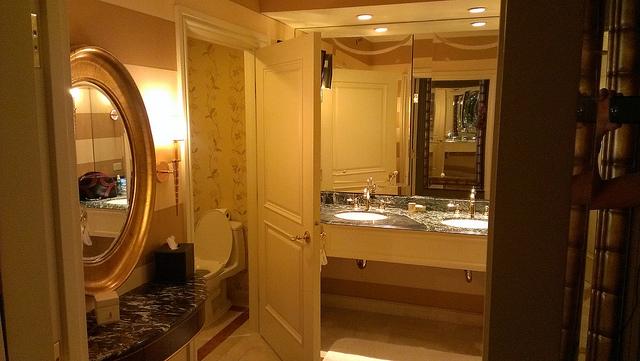What is the color scheme of this room?
Be succinct. Tan. Are the door knob lever style?
Keep it brief. Yes. Can you see more than one reflection?
Give a very brief answer. Yes. What comes out of the black box on the left counter?
Be succinct. Tissue. How many sinks are in the bathroom?
Quick response, please. 2. 